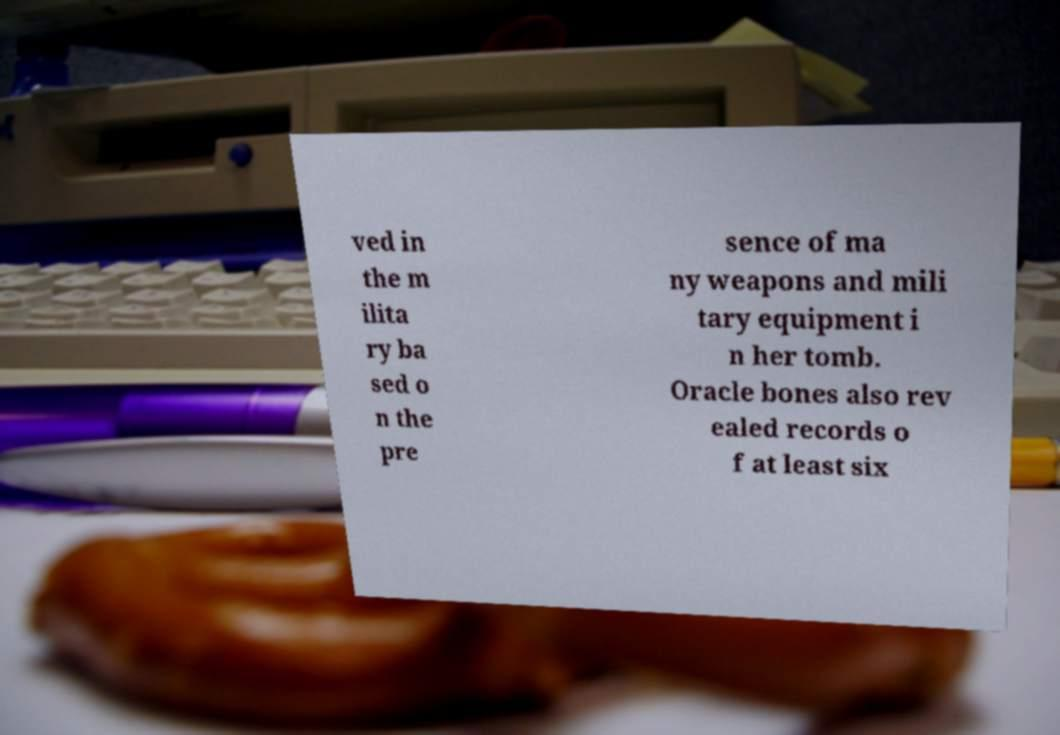There's text embedded in this image that I need extracted. Can you transcribe it verbatim? ved in the m ilita ry ba sed o n the pre sence of ma ny weapons and mili tary equipment i n her tomb. Oracle bones also rev ealed records o f at least six 